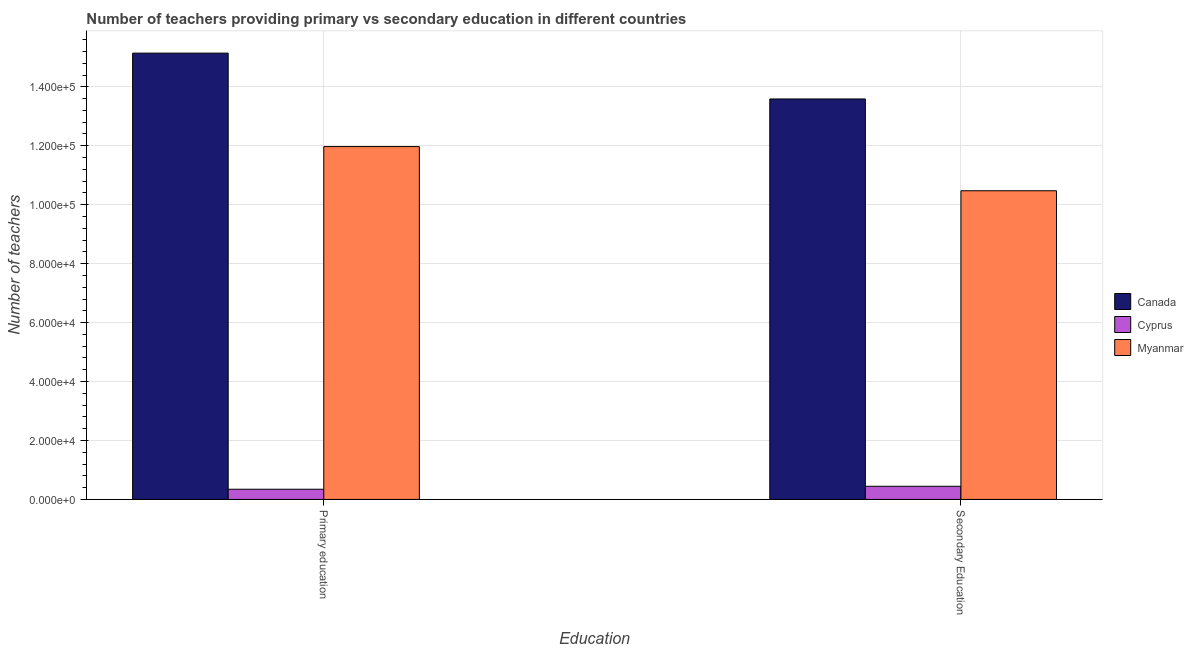How many groups of bars are there?
Provide a short and direct response. 2. Are the number of bars per tick equal to the number of legend labels?
Your response must be concise. Yes. What is the number of secondary teachers in Myanmar?
Provide a short and direct response. 1.05e+05. Across all countries, what is the maximum number of primary teachers?
Make the answer very short. 1.51e+05. Across all countries, what is the minimum number of primary teachers?
Provide a short and direct response. 3456. In which country was the number of primary teachers maximum?
Your response must be concise. Canada. In which country was the number of secondary teachers minimum?
Keep it short and to the point. Cyprus. What is the total number of secondary teachers in the graph?
Your answer should be very brief. 2.45e+05. What is the difference between the number of secondary teachers in Cyprus and that in Canada?
Provide a succinct answer. -1.31e+05. What is the difference between the number of secondary teachers in Canada and the number of primary teachers in Cyprus?
Give a very brief answer. 1.32e+05. What is the average number of secondary teachers per country?
Provide a succinct answer. 8.17e+04. What is the difference between the number of secondary teachers and number of primary teachers in Cyprus?
Provide a succinct answer. 1003. What is the ratio of the number of secondary teachers in Canada to that in Myanmar?
Ensure brevity in your answer.  1.3. What does the 1st bar from the left in Primary education represents?
Provide a short and direct response. Canada. What does the 3rd bar from the right in Secondary Education represents?
Offer a terse response. Canada. Are all the bars in the graph horizontal?
Your answer should be very brief. No. How many countries are there in the graph?
Make the answer very short. 3. Are the values on the major ticks of Y-axis written in scientific E-notation?
Ensure brevity in your answer.  Yes. Does the graph contain grids?
Your answer should be compact. Yes. What is the title of the graph?
Make the answer very short. Number of teachers providing primary vs secondary education in different countries. Does "Turkmenistan" appear as one of the legend labels in the graph?
Your response must be concise. No. What is the label or title of the X-axis?
Offer a very short reply. Education. What is the label or title of the Y-axis?
Keep it short and to the point. Number of teachers. What is the Number of teachers of Canada in Primary education?
Your answer should be very brief. 1.51e+05. What is the Number of teachers of Cyprus in Primary education?
Keep it short and to the point. 3456. What is the Number of teachers of Myanmar in Primary education?
Your response must be concise. 1.20e+05. What is the Number of teachers in Canada in Secondary Education?
Your response must be concise. 1.36e+05. What is the Number of teachers in Cyprus in Secondary Education?
Give a very brief answer. 4459. What is the Number of teachers of Myanmar in Secondary Education?
Keep it short and to the point. 1.05e+05. Across all Education, what is the maximum Number of teachers of Canada?
Give a very brief answer. 1.51e+05. Across all Education, what is the maximum Number of teachers of Cyprus?
Make the answer very short. 4459. Across all Education, what is the maximum Number of teachers in Myanmar?
Offer a very short reply. 1.20e+05. Across all Education, what is the minimum Number of teachers of Canada?
Your answer should be very brief. 1.36e+05. Across all Education, what is the minimum Number of teachers in Cyprus?
Your answer should be compact. 3456. Across all Education, what is the minimum Number of teachers in Myanmar?
Provide a succinct answer. 1.05e+05. What is the total Number of teachers in Canada in the graph?
Provide a succinct answer. 2.87e+05. What is the total Number of teachers of Cyprus in the graph?
Your answer should be very brief. 7915. What is the total Number of teachers in Myanmar in the graph?
Make the answer very short. 2.24e+05. What is the difference between the Number of teachers in Canada in Primary education and that in Secondary Education?
Your response must be concise. 1.55e+04. What is the difference between the Number of teachers in Cyprus in Primary education and that in Secondary Education?
Provide a short and direct response. -1003. What is the difference between the Number of teachers in Myanmar in Primary education and that in Secondary Education?
Make the answer very short. 1.50e+04. What is the difference between the Number of teachers of Canada in Primary education and the Number of teachers of Cyprus in Secondary Education?
Your answer should be compact. 1.47e+05. What is the difference between the Number of teachers of Canada in Primary education and the Number of teachers of Myanmar in Secondary Education?
Your answer should be very brief. 4.67e+04. What is the difference between the Number of teachers of Cyprus in Primary education and the Number of teachers of Myanmar in Secondary Education?
Ensure brevity in your answer.  -1.01e+05. What is the average Number of teachers in Canada per Education?
Your answer should be compact. 1.44e+05. What is the average Number of teachers of Cyprus per Education?
Provide a short and direct response. 3957.5. What is the average Number of teachers in Myanmar per Education?
Keep it short and to the point. 1.12e+05. What is the difference between the Number of teachers in Canada and Number of teachers in Cyprus in Primary education?
Provide a succinct answer. 1.48e+05. What is the difference between the Number of teachers in Canada and Number of teachers in Myanmar in Primary education?
Keep it short and to the point. 3.17e+04. What is the difference between the Number of teachers of Cyprus and Number of teachers of Myanmar in Primary education?
Give a very brief answer. -1.16e+05. What is the difference between the Number of teachers of Canada and Number of teachers of Cyprus in Secondary Education?
Ensure brevity in your answer.  1.31e+05. What is the difference between the Number of teachers of Canada and Number of teachers of Myanmar in Secondary Education?
Provide a succinct answer. 3.11e+04. What is the difference between the Number of teachers in Cyprus and Number of teachers in Myanmar in Secondary Education?
Your answer should be very brief. -1.00e+05. What is the ratio of the Number of teachers in Canada in Primary education to that in Secondary Education?
Provide a succinct answer. 1.11. What is the ratio of the Number of teachers in Cyprus in Primary education to that in Secondary Education?
Offer a very short reply. 0.78. What is the ratio of the Number of teachers of Myanmar in Primary education to that in Secondary Education?
Offer a very short reply. 1.14. What is the difference between the highest and the second highest Number of teachers of Canada?
Your answer should be compact. 1.55e+04. What is the difference between the highest and the second highest Number of teachers in Cyprus?
Your response must be concise. 1003. What is the difference between the highest and the second highest Number of teachers in Myanmar?
Your answer should be compact. 1.50e+04. What is the difference between the highest and the lowest Number of teachers in Canada?
Provide a succinct answer. 1.55e+04. What is the difference between the highest and the lowest Number of teachers of Cyprus?
Your response must be concise. 1003. What is the difference between the highest and the lowest Number of teachers in Myanmar?
Your response must be concise. 1.50e+04. 